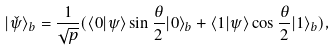<formula> <loc_0><loc_0><loc_500><loc_500>| \check { \psi } \rangle _ { b } = \frac { 1 } { \sqrt { p } } ( \langle 0 | \psi \rangle \sin \frac { \theta } { 2 } | 0 \rangle _ { b } + \langle 1 | \psi \rangle \cos \frac { \theta } { 2 } | 1 \rangle _ { b } ) ,</formula> 